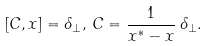<formula> <loc_0><loc_0><loc_500><loc_500>[ C , x ] = \delta _ { \perp } , \, C = \frac { 1 } { x ^ { * } - x } \, \delta _ { \perp } .</formula> 